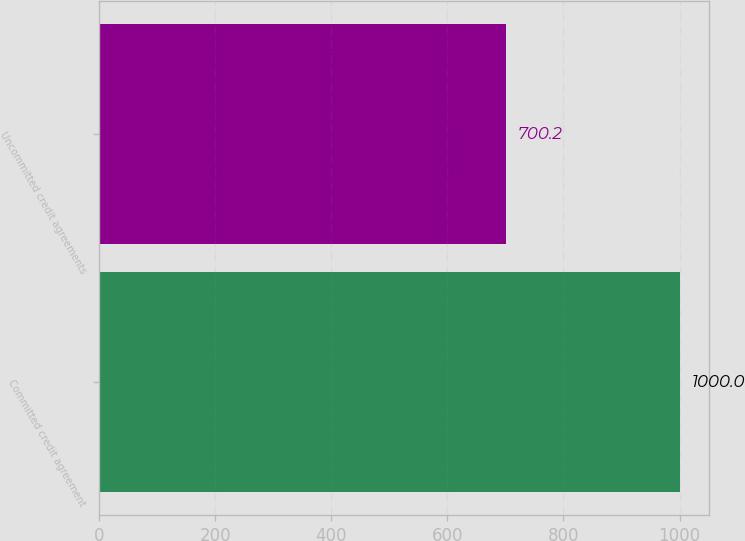Convert chart. <chart><loc_0><loc_0><loc_500><loc_500><bar_chart><fcel>Committed credit agreement<fcel>Uncommitted credit agreements<nl><fcel>1000<fcel>700.2<nl></chart> 